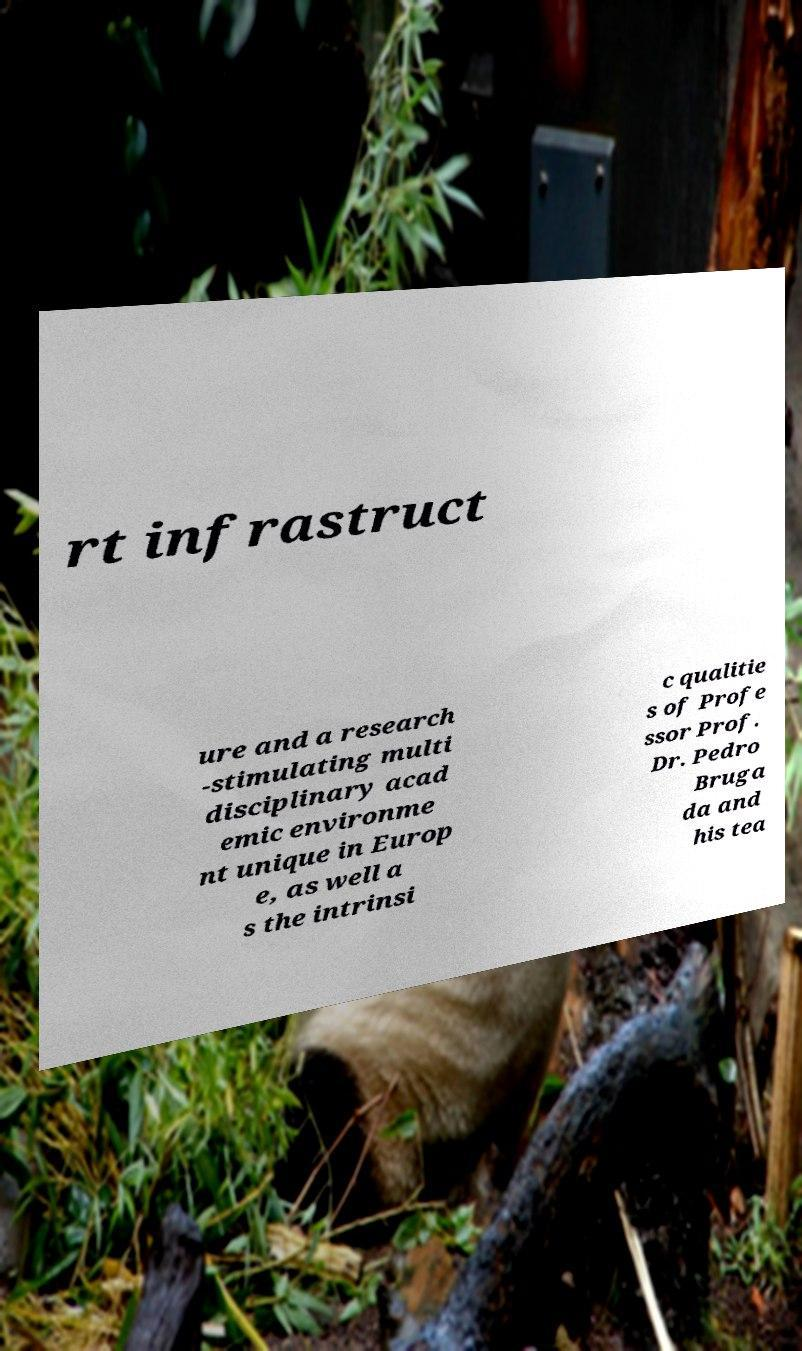Could you extract and type out the text from this image? rt infrastruct ure and a research -stimulating multi disciplinary acad emic environme nt unique in Europ e, as well a s the intrinsi c qualitie s of Profe ssor Prof. Dr. Pedro Bruga da and his tea 